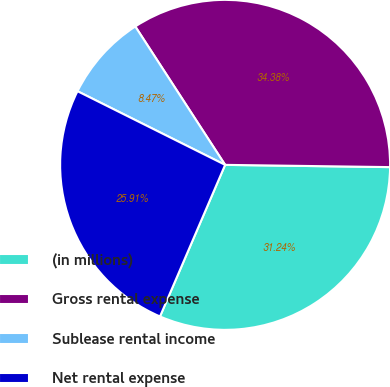Convert chart. <chart><loc_0><loc_0><loc_500><loc_500><pie_chart><fcel>(in millions)<fcel>Gross rental expense<fcel>Sublease rental income<fcel>Net rental expense<nl><fcel>31.24%<fcel>34.38%<fcel>8.47%<fcel>25.91%<nl></chart> 